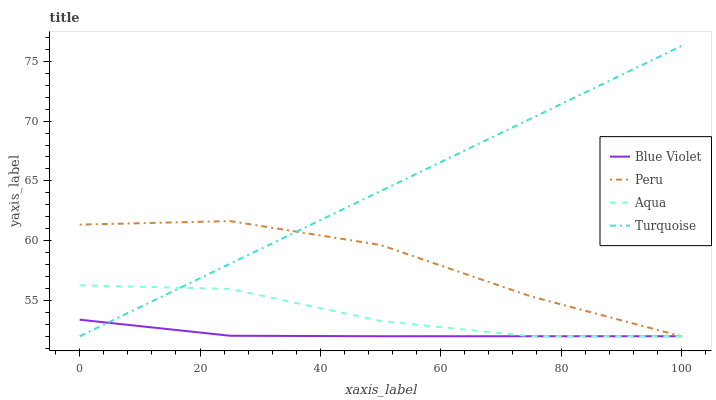Does Blue Violet have the minimum area under the curve?
Answer yes or no. Yes. Does Turquoise have the maximum area under the curve?
Answer yes or no. Yes. Does Aqua have the minimum area under the curve?
Answer yes or no. No. Does Aqua have the maximum area under the curve?
Answer yes or no. No. Is Turquoise the smoothest?
Answer yes or no. Yes. Is Peru the roughest?
Answer yes or no. Yes. Is Aqua the smoothest?
Answer yes or no. No. Is Aqua the roughest?
Answer yes or no. No. Does Turquoise have the highest value?
Answer yes or no. Yes. Does Aqua have the highest value?
Answer yes or no. No. Does Turquoise intersect Peru?
Answer yes or no. Yes. Is Turquoise less than Peru?
Answer yes or no. No. Is Turquoise greater than Peru?
Answer yes or no. No. 